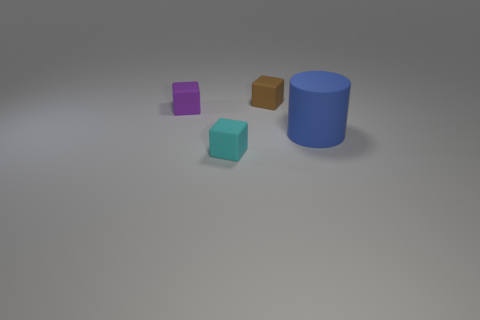How many things are either small purple matte spheres or blocks to the left of the tiny brown cube?
Provide a short and direct response. 2. There is a purple rubber object; how many cubes are behind it?
Your answer should be compact. 1. There is a big cylinder that is the same material as the brown cube; what is its color?
Offer a very short reply. Blue. What number of metallic things are either blue cylinders or green things?
Provide a succinct answer. 0. What is the shape of the big blue object that is in front of the small purple rubber cube?
Provide a succinct answer. Cylinder. There is a tiny object in front of the small purple block; is there a thing behind it?
Offer a very short reply. Yes. Are there any other blocks that have the same size as the purple rubber block?
Make the answer very short. Yes. How big is the purple rubber thing?
Offer a terse response. Small. There is a thing right of the rubber object behind the tiny purple object; what is its size?
Offer a terse response. Large. How many tiny brown objects are there?
Offer a terse response. 1. 